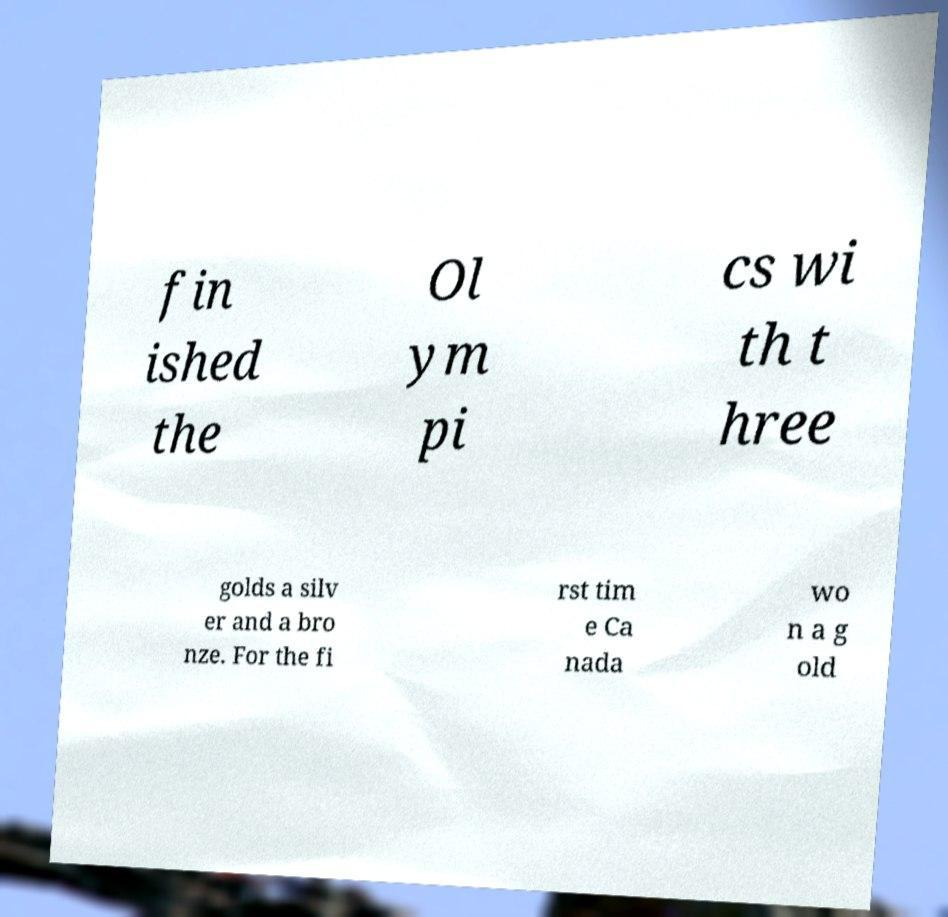There's text embedded in this image that I need extracted. Can you transcribe it verbatim? fin ished the Ol ym pi cs wi th t hree golds a silv er and a bro nze. For the fi rst tim e Ca nada wo n a g old 